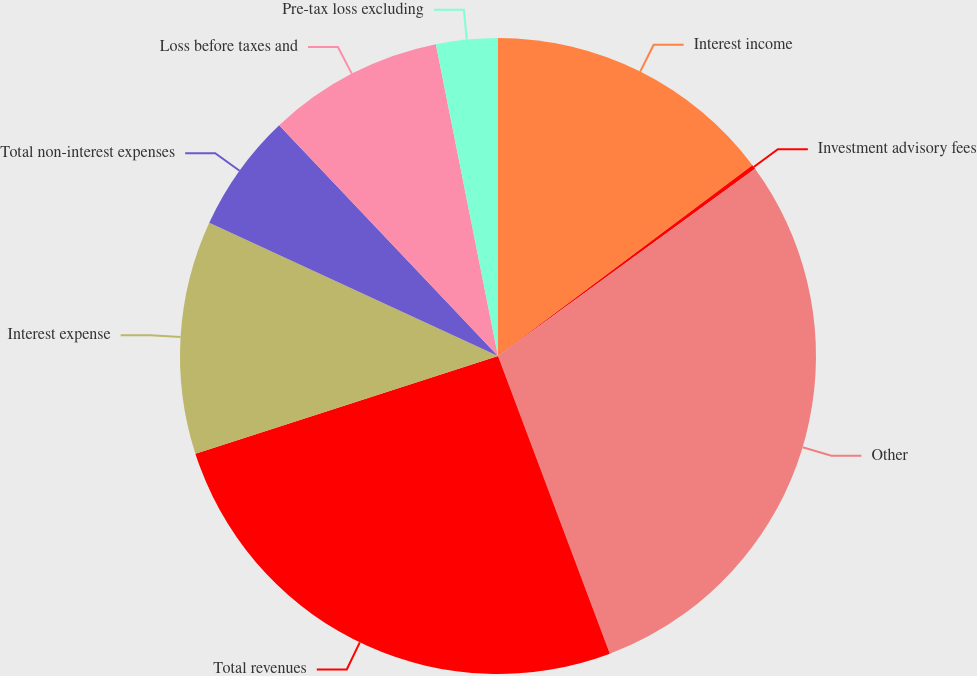Convert chart. <chart><loc_0><loc_0><loc_500><loc_500><pie_chart><fcel>Interest income<fcel>Investment advisory fees<fcel>Other<fcel>Total revenues<fcel>Interest expense<fcel>Total non-interest expenses<fcel>Loss before taxes and<fcel>Pre-tax loss excluding<nl><fcel>14.76%<fcel>0.22%<fcel>29.3%<fcel>25.75%<fcel>11.85%<fcel>6.04%<fcel>8.95%<fcel>3.13%<nl></chart> 